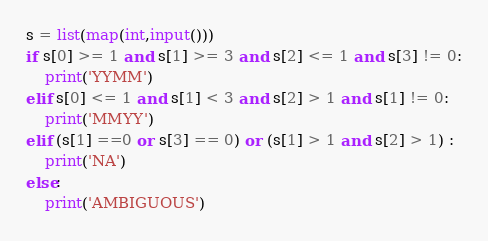<code> <loc_0><loc_0><loc_500><loc_500><_Python_>s = list(map(int,input()))
if s[0] >= 1 and s[1] >= 3 and s[2] <= 1 and s[3] != 0:
    print('YYMM')
elif s[0] <= 1 and s[1] < 3 and s[2] > 1 and s[1] != 0:
    print('MMYY')
elif (s[1] ==0 or s[3] == 0) or (s[1] > 1 and s[2] > 1) :
    print('NA')
else:
    print('AMBIGUOUS')</code> 